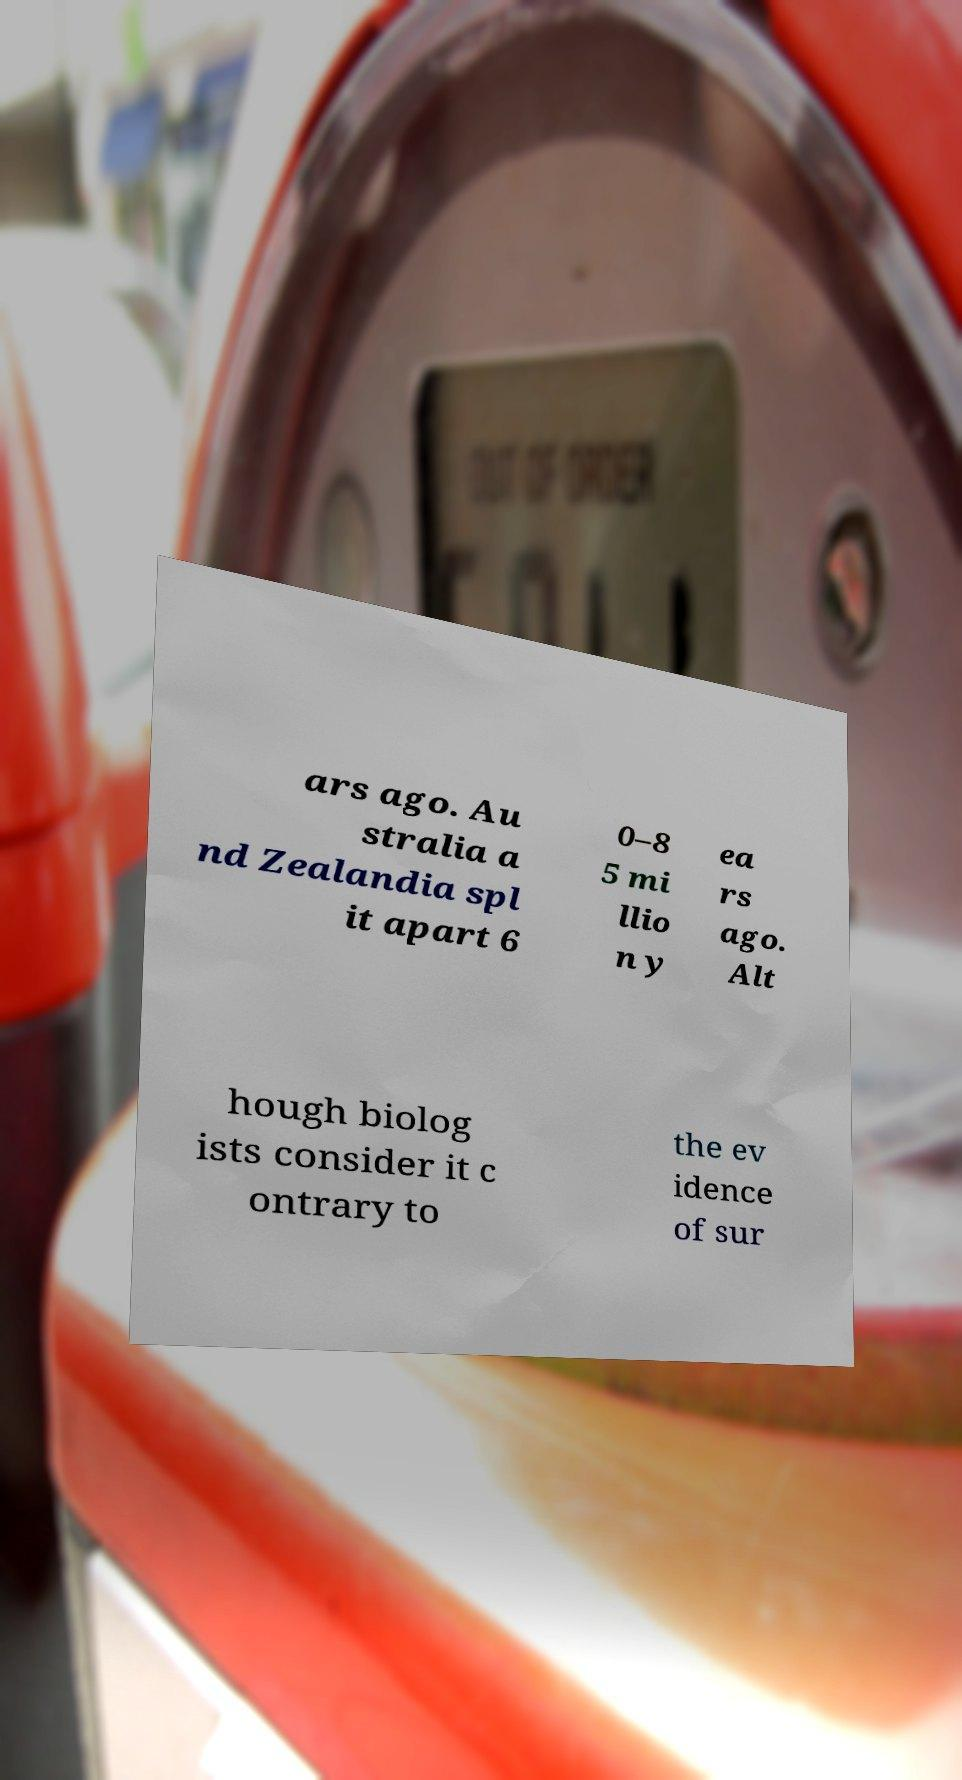Can you accurately transcribe the text from the provided image for me? ars ago. Au stralia a nd Zealandia spl it apart 6 0–8 5 mi llio n y ea rs ago. Alt hough biolog ists consider it c ontrary to the ev idence of sur 